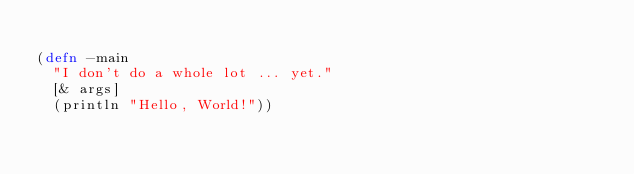Convert code to text. <code><loc_0><loc_0><loc_500><loc_500><_Clojure_>
(defn -main
  "I don't do a whole lot ... yet."
  [& args]
  (println "Hello, World!"))
</code> 